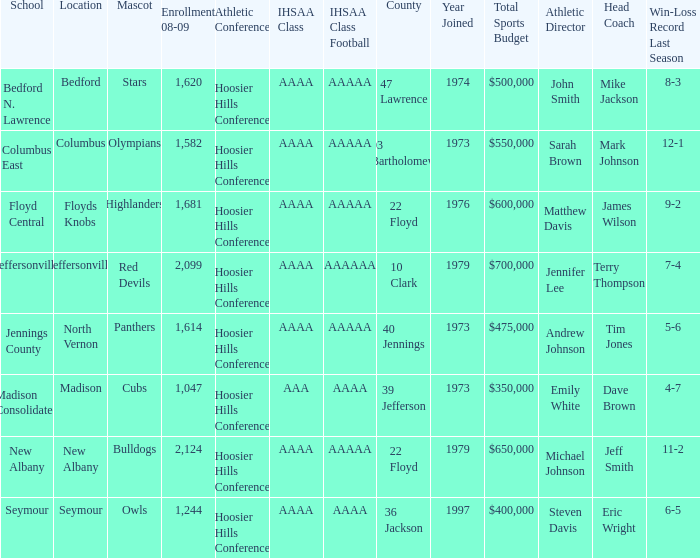Would you be able to parse every entry in this table? {'header': ['School', 'Location', 'Mascot', 'Enrollment 08-09', 'Athletic Conference', 'IHSAA Class', 'IHSAA Class Football', 'County', 'Year Joined', 'Total Sports Budget', 'Athletic Director', 'Head Coach', 'Win-Loss Record Last Season'], 'rows': [['Bedford N. Lawrence', 'Bedford', 'Stars', '1,620', 'Hoosier Hills Conference', 'AAAA', 'AAAAA', '47 Lawrence', '1974', '$500,000', 'John Smith', 'Mike Jackson', '8-3'], ['Columbus East', 'Columbus', 'Olympians', '1,582', 'Hoosier Hills Conference', 'AAAA', 'AAAAA', '03 Bartholomew', '1973', '$550,000', 'Sarah Brown', 'Mark Johnson', '12-1'], ['Floyd Central', 'Floyds Knobs', 'Highlanders', '1,681', 'Hoosier Hills Conference', 'AAAA', 'AAAAA', '22 Floyd', '1976', '$600,000', 'Matthew Davis', 'James Wilson', '9-2'], ['Jeffersonville', 'Jeffersonville', 'Red Devils', '2,099', 'Hoosier Hills Conference', 'AAAA', 'AAAAAA', '10 Clark', '1979', '$700,000', 'Jennifer Lee', 'Terry Thompson', '7-4'], ['Jennings County', 'North Vernon', 'Panthers', '1,614', 'Hoosier Hills Conference', 'AAAA', 'AAAAA', '40 Jennings', '1973', '$475,000', 'Andrew Johnson', 'Tim Jones', '5-6'], ['Madison Consolidated', 'Madison', 'Cubs', '1,047', 'Hoosier Hills Conference', 'AAA', 'AAAA', '39 Jefferson', '1973', '$350,000', 'Emily White', 'Dave Brown', '4-7'], ['New Albany', 'New Albany', 'Bulldogs', '2,124', 'Hoosier Hills Conference', 'AAAA', 'AAAAA', '22 Floyd', '1979', '$650,000', 'Michael Johnson', 'Jeff Smith', '11-2'], ['Seymour', 'Seymour', 'Owls', '1,244', 'Hoosier Hills Conference', 'AAAA', 'AAAA', '36 Jackson', '1997', '$400,000', 'Steven Davis', 'Eric Wright', '6-5']]} What's the IHSAA Class Football if the panthers are the mascot? AAAAA. 